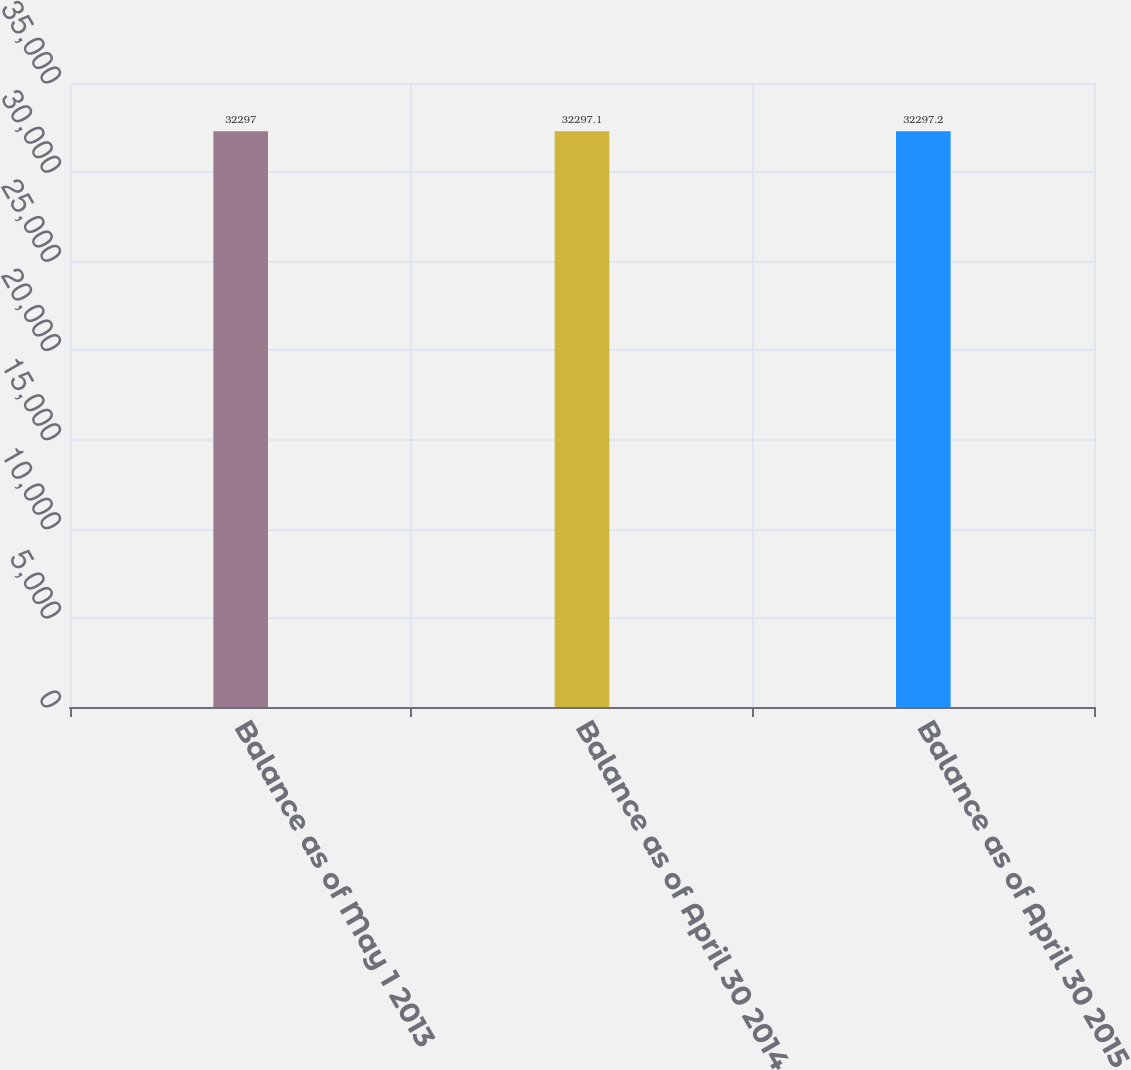Convert chart. <chart><loc_0><loc_0><loc_500><loc_500><bar_chart><fcel>Balance as of May 1 2013<fcel>Balance as of April 30 2014<fcel>Balance as of April 30 2015<nl><fcel>32297<fcel>32297.1<fcel>32297.2<nl></chart> 